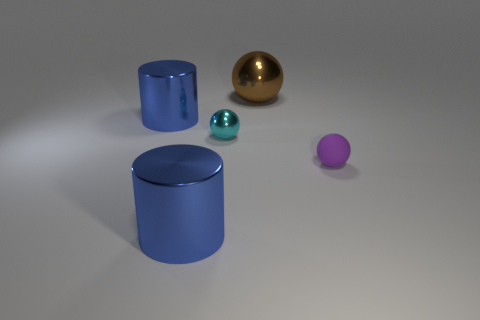Add 5 large blue metallic cylinders. How many objects exist? 10 Subtract all spheres. How many objects are left? 2 Subtract all blue cylinders. Subtract all small shiny spheres. How many objects are left? 2 Add 2 purple matte objects. How many purple matte objects are left? 3 Add 4 big brown matte blocks. How many big brown matte blocks exist? 4 Subtract 0 blue cubes. How many objects are left? 5 